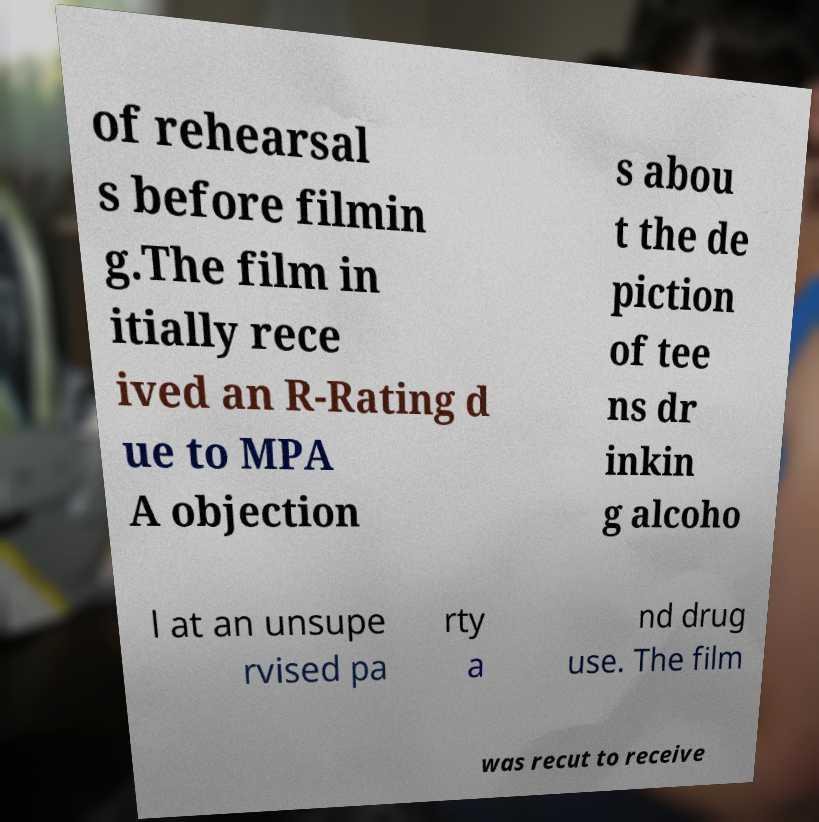Can you accurately transcribe the text from the provided image for me? of rehearsal s before filmin g.The film in itially rece ived an R-Rating d ue to MPA A objection s abou t the de piction of tee ns dr inkin g alcoho l at an unsupe rvised pa rty a nd drug use. The film was recut to receive 